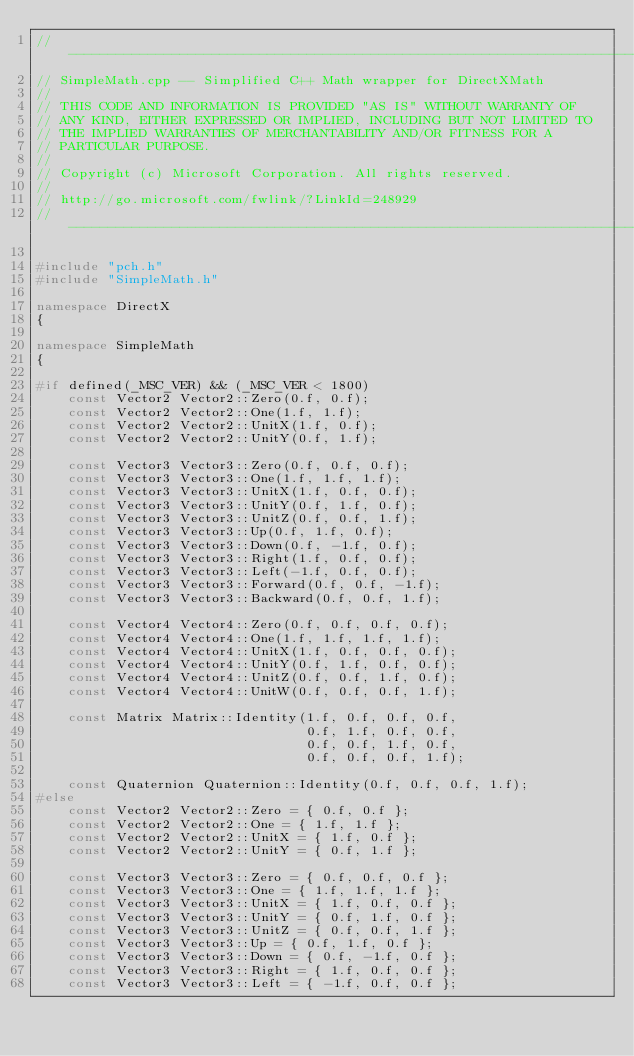Convert code to text. <code><loc_0><loc_0><loc_500><loc_500><_C++_>//-------------------------------------------------------------------------------------
// SimpleMath.cpp -- Simplified C++ Math wrapper for DirectXMath
//
// THIS CODE AND INFORMATION IS PROVIDED "AS IS" WITHOUT WARRANTY OF
// ANY KIND, EITHER EXPRESSED OR IMPLIED, INCLUDING BUT NOT LIMITED TO
// THE IMPLIED WARRANTIES OF MERCHANTABILITY AND/OR FITNESS FOR A
// PARTICULAR PURPOSE.
//  
// Copyright (c) Microsoft Corporation. All rights reserved.
//
// http://go.microsoft.com/fwlink/?LinkId=248929
//-------------------------------------------------------------------------------------

#include "pch.h"
#include "SimpleMath.h"

namespace DirectX
{

namespace SimpleMath
{

#if defined(_MSC_VER) && (_MSC_VER < 1800)
    const Vector2 Vector2::Zero(0.f, 0.f);
    const Vector2 Vector2::One(1.f, 1.f);
    const Vector2 Vector2::UnitX(1.f, 0.f);
    const Vector2 Vector2::UnitY(0.f, 1.f);

    const Vector3 Vector3::Zero(0.f, 0.f, 0.f);
    const Vector3 Vector3::One(1.f, 1.f, 1.f);
    const Vector3 Vector3::UnitX(1.f, 0.f, 0.f);
    const Vector3 Vector3::UnitY(0.f, 1.f, 0.f);
    const Vector3 Vector3::UnitZ(0.f, 0.f, 1.f);
    const Vector3 Vector3::Up(0.f, 1.f, 0.f);
    const Vector3 Vector3::Down(0.f, -1.f, 0.f);
    const Vector3 Vector3::Right(1.f, 0.f, 0.f);
    const Vector3 Vector3::Left(-1.f, 0.f, 0.f);
    const Vector3 Vector3::Forward(0.f, 0.f, -1.f);
    const Vector3 Vector3::Backward(0.f, 0.f, 1.f);

    const Vector4 Vector4::Zero(0.f, 0.f, 0.f, 0.f);
    const Vector4 Vector4::One(1.f, 1.f, 1.f, 1.f);
    const Vector4 Vector4::UnitX(1.f, 0.f, 0.f, 0.f);
    const Vector4 Vector4::UnitY(0.f, 1.f, 0.f, 0.f);
    const Vector4 Vector4::UnitZ(0.f, 0.f, 1.f, 0.f);
    const Vector4 Vector4::UnitW(0.f, 0.f, 0.f, 1.f);

    const Matrix Matrix::Identity(1.f, 0.f, 0.f, 0.f,
                                  0.f, 1.f, 0.f, 0.f,
                                  0.f, 0.f, 1.f, 0.f,
                                  0.f, 0.f, 0.f, 1.f);

    const Quaternion Quaternion::Identity(0.f, 0.f, 0.f, 1.f);
#else
    const Vector2 Vector2::Zero = { 0.f, 0.f };
    const Vector2 Vector2::One = { 1.f, 1.f };
    const Vector2 Vector2::UnitX = { 1.f, 0.f };
    const Vector2 Vector2::UnitY = { 0.f, 1.f };

    const Vector3 Vector3::Zero = { 0.f, 0.f, 0.f };
    const Vector3 Vector3::One = { 1.f, 1.f, 1.f };
    const Vector3 Vector3::UnitX = { 1.f, 0.f, 0.f };
    const Vector3 Vector3::UnitY = { 0.f, 1.f, 0.f };
    const Vector3 Vector3::UnitZ = { 0.f, 0.f, 1.f };
    const Vector3 Vector3::Up = { 0.f, 1.f, 0.f };
    const Vector3 Vector3::Down = { 0.f, -1.f, 0.f };
    const Vector3 Vector3::Right = { 1.f, 0.f, 0.f };
    const Vector3 Vector3::Left = { -1.f, 0.f, 0.f };</code> 